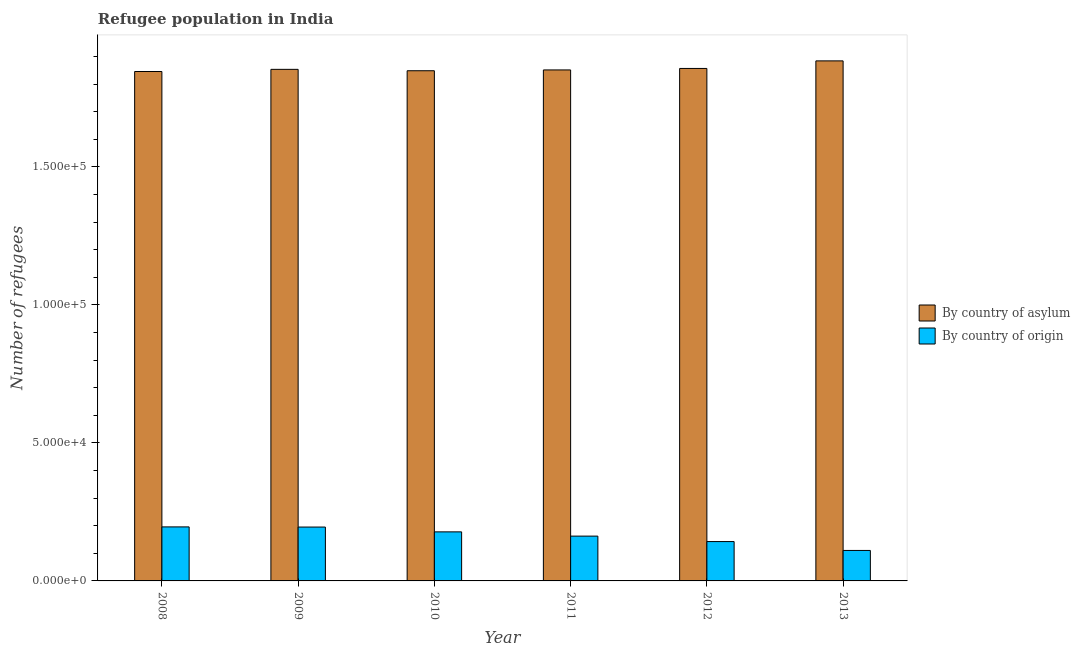How many different coloured bars are there?
Your response must be concise. 2. How many groups of bars are there?
Your answer should be very brief. 6. Are the number of bars on each tick of the X-axis equal?
Provide a succinct answer. Yes. What is the number of refugees by country of origin in 2013?
Offer a terse response. 1.10e+04. Across all years, what is the maximum number of refugees by country of origin?
Provide a short and direct response. 1.96e+04. Across all years, what is the minimum number of refugees by country of origin?
Make the answer very short. 1.10e+04. In which year was the number of refugees by country of asylum maximum?
Your answer should be very brief. 2013. In which year was the number of refugees by country of origin minimum?
Your answer should be compact. 2013. What is the total number of refugees by country of asylum in the graph?
Your response must be concise. 1.11e+06. What is the difference between the number of refugees by country of asylum in 2008 and that in 2010?
Your answer should be compact. -278. What is the difference between the number of refugees by country of origin in 2008 and the number of refugees by country of asylum in 2012?
Provide a succinct answer. 5311. What is the average number of refugees by country of origin per year?
Give a very brief answer. 1.64e+04. In how many years, is the number of refugees by country of origin greater than 20000?
Ensure brevity in your answer.  0. What is the ratio of the number of refugees by country of origin in 2008 to that in 2009?
Your response must be concise. 1. Is the number of refugees by country of asylum in 2010 less than that in 2013?
Offer a terse response. Yes. Is the difference between the number of refugees by country of asylum in 2009 and 2010 greater than the difference between the number of refugees by country of origin in 2009 and 2010?
Provide a succinct answer. No. What is the difference between the highest and the second highest number of refugees by country of origin?
Give a very brief answer. 55. What is the difference between the highest and the lowest number of refugees by country of origin?
Give a very brief answer. 8527. Is the sum of the number of refugees by country of asylum in 2010 and 2012 greater than the maximum number of refugees by country of origin across all years?
Your response must be concise. Yes. What does the 2nd bar from the left in 2013 represents?
Offer a terse response. By country of origin. What does the 1st bar from the right in 2009 represents?
Ensure brevity in your answer.  By country of origin. What is the difference between two consecutive major ticks on the Y-axis?
Keep it short and to the point. 5.00e+04. Are the values on the major ticks of Y-axis written in scientific E-notation?
Your answer should be very brief. Yes. Does the graph contain grids?
Provide a succinct answer. No. How many legend labels are there?
Your response must be concise. 2. How are the legend labels stacked?
Your response must be concise. Vertical. What is the title of the graph?
Your response must be concise. Refugee population in India. Does "Adolescent fertility rate" appear as one of the legend labels in the graph?
Keep it short and to the point. No. What is the label or title of the X-axis?
Provide a short and direct response. Year. What is the label or title of the Y-axis?
Provide a short and direct response. Number of refugees. What is the Number of refugees in By country of asylum in 2008?
Ensure brevity in your answer.  1.85e+05. What is the Number of refugees of By country of origin in 2008?
Provide a short and direct response. 1.96e+04. What is the Number of refugees of By country of asylum in 2009?
Make the answer very short. 1.85e+05. What is the Number of refugees in By country of origin in 2009?
Your response must be concise. 1.95e+04. What is the Number of refugees in By country of asylum in 2010?
Your answer should be very brief. 1.85e+05. What is the Number of refugees of By country of origin in 2010?
Give a very brief answer. 1.78e+04. What is the Number of refugees in By country of asylum in 2011?
Provide a short and direct response. 1.85e+05. What is the Number of refugees in By country of origin in 2011?
Provide a short and direct response. 1.62e+04. What is the Number of refugees of By country of asylum in 2012?
Give a very brief answer. 1.86e+05. What is the Number of refugees in By country of origin in 2012?
Provide a succinct answer. 1.43e+04. What is the Number of refugees in By country of asylum in 2013?
Your response must be concise. 1.88e+05. What is the Number of refugees of By country of origin in 2013?
Your response must be concise. 1.10e+04. Across all years, what is the maximum Number of refugees of By country of asylum?
Your response must be concise. 1.88e+05. Across all years, what is the maximum Number of refugees in By country of origin?
Give a very brief answer. 1.96e+04. Across all years, what is the minimum Number of refugees in By country of asylum?
Provide a short and direct response. 1.85e+05. Across all years, what is the minimum Number of refugees of By country of origin?
Make the answer very short. 1.10e+04. What is the total Number of refugees of By country of asylum in the graph?
Ensure brevity in your answer.  1.11e+06. What is the total Number of refugees in By country of origin in the graph?
Make the answer very short. 9.84e+04. What is the difference between the Number of refugees in By country of asylum in 2008 and that in 2009?
Give a very brief answer. -780. What is the difference between the Number of refugees of By country of asylum in 2008 and that in 2010?
Provide a short and direct response. -278. What is the difference between the Number of refugees of By country of origin in 2008 and that in 2010?
Your answer should be very brief. 1800. What is the difference between the Number of refugees in By country of asylum in 2008 and that in 2011?
Give a very brief answer. -575. What is the difference between the Number of refugees in By country of origin in 2008 and that in 2011?
Make the answer very short. 3337. What is the difference between the Number of refugees in By country of asylum in 2008 and that in 2012?
Your answer should be compact. -1113. What is the difference between the Number of refugees of By country of origin in 2008 and that in 2012?
Keep it short and to the point. 5311. What is the difference between the Number of refugees in By country of asylum in 2008 and that in 2013?
Offer a terse response. -3852. What is the difference between the Number of refugees in By country of origin in 2008 and that in 2013?
Make the answer very short. 8527. What is the difference between the Number of refugees of By country of asylum in 2009 and that in 2010?
Your response must be concise. 502. What is the difference between the Number of refugees of By country of origin in 2009 and that in 2010?
Ensure brevity in your answer.  1745. What is the difference between the Number of refugees of By country of asylum in 2009 and that in 2011?
Make the answer very short. 205. What is the difference between the Number of refugees of By country of origin in 2009 and that in 2011?
Your answer should be compact. 3282. What is the difference between the Number of refugees in By country of asylum in 2009 and that in 2012?
Offer a very short reply. -333. What is the difference between the Number of refugees of By country of origin in 2009 and that in 2012?
Your answer should be very brief. 5256. What is the difference between the Number of refugees in By country of asylum in 2009 and that in 2013?
Provide a short and direct response. -3072. What is the difference between the Number of refugees in By country of origin in 2009 and that in 2013?
Give a very brief answer. 8472. What is the difference between the Number of refugees in By country of asylum in 2010 and that in 2011?
Offer a very short reply. -297. What is the difference between the Number of refugees of By country of origin in 2010 and that in 2011?
Offer a terse response. 1537. What is the difference between the Number of refugees of By country of asylum in 2010 and that in 2012?
Offer a very short reply. -835. What is the difference between the Number of refugees in By country of origin in 2010 and that in 2012?
Ensure brevity in your answer.  3511. What is the difference between the Number of refugees of By country of asylum in 2010 and that in 2013?
Your answer should be very brief. -3574. What is the difference between the Number of refugees of By country of origin in 2010 and that in 2013?
Ensure brevity in your answer.  6727. What is the difference between the Number of refugees of By country of asylum in 2011 and that in 2012?
Keep it short and to the point. -538. What is the difference between the Number of refugees in By country of origin in 2011 and that in 2012?
Keep it short and to the point. 1974. What is the difference between the Number of refugees of By country of asylum in 2011 and that in 2013?
Your answer should be very brief. -3277. What is the difference between the Number of refugees of By country of origin in 2011 and that in 2013?
Offer a very short reply. 5190. What is the difference between the Number of refugees of By country of asylum in 2012 and that in 2013?
Your answer should be compact. -2739. What is the difference between the Number of refugees in By country of origin in 2012 and that in 2013?
Ensure brevity in your answer.  3216. What is the difference between the Number of refugees of By country of asylum in 2008 and the Number of refugees of By country of origin in 2009?
Offer a very short reply. 1.65e+05. What is the difference between the Number of refugees in By country of asylum in 2008 and the Number of refugees in By country of origin in 2010?
Provide a succinct answer. 1.67e+05. What is the difference between the Number of refugees in By country of asylum in 2008 and the Number of refugees in By country of origin in 2011?
Offer a terse response. 1.68e+05. What is the difference between the Number of refugees of By country of asylum in 2008 and the Number of refugees of By country of origin in 2012?
Give a very brief answer. 1.70e+05. What is the difference between the Number of refugees in By country of asylum in 2008 and the Number of refugees in By country of origin in 2013?
Keep it short and to the point. 1.74e+05. What is the difference between the Number of refugees of By country of asylum in 2009 and the Number of refugees of By country of origin in 2010?
Provide a short and direct response. 1.68e+05. What is the difference between the Number of refugees in By country of asylum in 2009 and the Number of refugees in By country of origin in 2011?
Ensure brevity in your answer.  1.69e+05. What is the difference between the Number of refugees in By country of asylum in 2009 and the Number of refugees in By country of origin in 2012?
Give a very brief answer. 1.71e+05. What is the difference between the Number of refugees in By country of asylum in 2009 and the Number of refugees in By country of origin in 2013?
Your response must be concise. 1.74e+05. What is the difference between the Number of refugees in By country of asylum in 2010 and the Number of refugees in By country of origin in 2011?
Your answer should be compact. 1.69e+05. What is the difference between the Number of refugees of By country of asylum in 2010 and the Number of refugees of By country of origin in 2012?
Provide a succinct answer. 1.71e+05. What is the difference between the Number of refugees of By country of asylum in 2010 and the Number of refugees of By country of origin in 2013?
Your answer should be very brief. 1.74e+05. What is the difference between the Number of refugees of By country of asylum in 2011 and the Number of refugees of By country of origin in 2012?
Keep it short and to the point. 1.71e+05. What is the difference between the Number of refugees in By country of asylum in 2011 and the Number of refugees in By country of origin in 2013?
Ensure brevity in your answer.  1.74e+05. What is the difference between the Number of refugees in By country of asylum in 2012 and the Number of refugees in By country of origin in 2013?
Give a very brief answer. 1.75e+05. What is the average Number of refugees of By country of asylum per year?
Give a very brief answer. 1.86e+05. What is the average Number of refugees in By country of origin per year?
Offer a terse response. 1.64e+04. In the year 2008, what is the difference between the Number of refugees of By country of asylum and Number of refugees of By country of origin?
Offer a terse response. 1.65e+05. In the year 2009, what is the difference between the Number of refugees of By country of asylum and Number of refugees of By country of origin?
Offer a very short reply. 1.66e+05. In the year 2010, what is the difference between the Number of refugees in By country of asylum and Number of refugees in By country of origin?
Your response must be concise. 1.67e+05. In the year 2011, what is the difference between the Number of refugees in By country of asylum and Number of refugees in By country of origin?
Your answer should be very brief. 1.69e+05. In the year 2012, what is the difference between the Number of refugees of By country of asylum and Number of refugees of By country of origin?
Offer a terse response. 1.71e+05. In the year 2013, what is the difference between the Number of refugees in By country of asylum and Number of refugees in By country of origin?
Your response must be concise. 1.77e+05. What is the ratio of the Number of refugees in By country of asylum in 2008 to that in 2009?
Provide a short and direct response. 1. What is the ratio of the Number of refugees of By country of asylum in 2008 to that in 2010?
Provide a succinct answer. 1. What is the ratio of the Number of refugees of By country of origin in 2008 to that in 2010?
Keep it short and to the point. 1.1. What is the ratio of the Number of refugees of By country of asylum in 2008 to that in 2011?
Offer a terse response. 1. What is the ratio of the Number of refugees of By country of origin in 2008 to that in 2011?
Provide a short and direct response. 1.21. What is the ratio of the Number of refugees of By country of origin in 2008 to that in 2012?
Offer a very short reply. 1.37. What is the ratio of the Number of refugees in By country of asylum in 2008 to that in 2013?
Make the answer very short. 0.98. What is the ratio of the Number of refugees in By country of origin in 2008 to that in 2013?
Your answer should be very brief. 1.77. What is the ratio of the Number of refugees in By country of origin in 2009 to that in 2010?
Provide a succinct answer. 1.1. What is the ratio of the Number of refugees in By country of asylum in 2009 to that in 2011?
Offer a very short reply. 1. What is the ratio of the Number of refugees of By country of origin in 2009 to that in 2011?
Offer a terse response. 1.2. What is the ratio of the Number of refugees of By country of asylum in 2009 to that in 2012?
Provide a short and direct response. 1. What is the ratio of the Number of refugees in By country of origin in 2009 to that in 2012?
Provide a succinct answer. 1.37. What is the ratio of the Number of refugees in By country of asylum in 2009 to that in 2013?
Offer a terse response. 0.98. What is the ratio of the Number of refugees of By country of origin in 2009 to that in 2013?
Provide a short and direct response. 1.77. What is the ratio of the Number of refugees of By country of asylum in 2010 to that in 2011?
Keep it short and to the point. 1. What is the ratio of the Number of refugees in By country of origin in 2010 to that in 2011?
Your answer should be very brief. 1.09. What is the ratio of the Number of refugees of By country of asylum in 2010 to that in 2012?
Provide a succinct answer. 1. What is the ratio of the Number of refugees in By country of origin in 2010 to that in 2012?
Your answer should be compact. 1.25. What is the ratio of the Number of refugees in By country of origin in 2010 to that in 2013?
Keep it short and to the point. 1.61. What is the ratio of the Number of refugees in By country of origin in 2011 to that in 2012?
Give a very brief answer. 1.14. What is the ratio of the Number of refugees in By country of asylum in 2011 to that in 2013?
Provide a succinct answer. 0.98. What is the ratio of the Number of refugees in By country of origin in 2011 to that in 2013?
Offer a very short reply. 1.47. What is the ratio of the Number of refugees in By country of asylum in 2012 to that in 2013?
Ensure brevity in your answer.  0.99. What is the ratio of the Number of refugees in By country of origin in 2012 to that in 2013?
Offer a terse response. 1.29. What is the difference between the highest and the second highest Number of refugees in By country of asylum?
Your answer should be very brief. 2739. What is the difference between the highest and the second highest Number of refugees in By country of origin?
Offer a terse response. 55. What is the difference between the highest and the lowest Number of refugees in By country of asylum?
Your answer should be compact. 3852. What is the difference between the highest and the lowest Number of refugees of By country of origin?
Your answer should be very brief. 8527. 